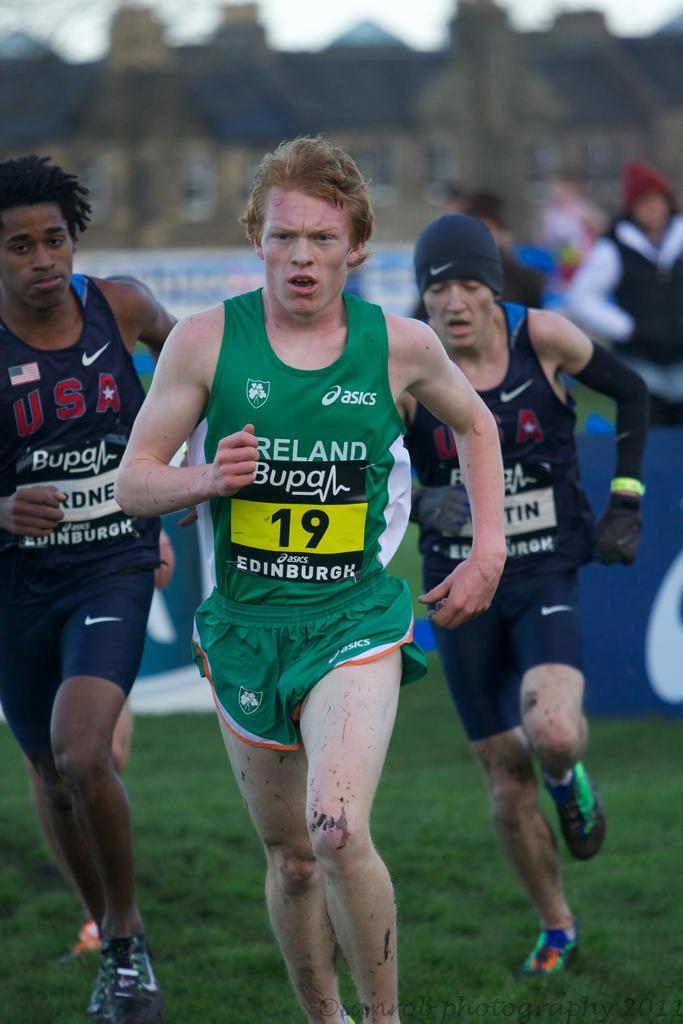Please provide a concise description of this image. In this picture there are three people running. At the back there are three people and there are boards and there is text on the board and there is a building. At the top there is sky. At the bottom there is grass. 